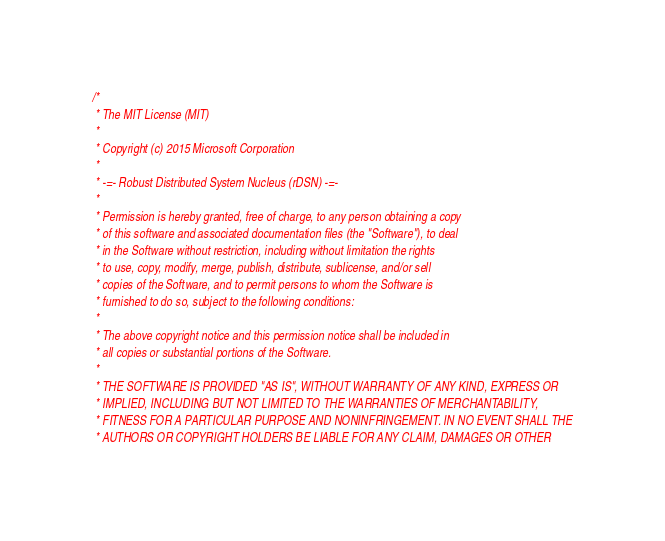Convert code to text. <code><loc_0><loc_0><loc_500><loc_500><_C++_>/*
 * The MIT License (MIT)
 *
 * Copyright (c) 2015 Microsoft Corporation
 *
 * -=- Robust Distributed System Nucleus (rDSN) -=-
 *
 * Permission is hereby granted, free of charge, to any person obtaining a copy
 * of this software and associated documentation files (the "Software"), to deal
 * in the Software without restriction, including without limitation the rights
 * to use, copy, modify, merge, publish, distribute, sublicense, and/or sell
 * copies of the Software, and to permit persons to whom the Software is
 * furnished to do so, subject to the following conditions:
 *
 * The above copyright notice and this permission notice shall be included in
 * all copies or substantial portions of the Software.
 *
 * THE SOFTWARE IS PROVIDED "AS IS", WITHOUT WARRANTY OF ANY KIND, EXPRESS OR
 * IMPLIED, INCLUDING BUT NOT LIMITED TO THE WARRANTIES OF MERCHANTABILITY,
 * FITNESS FOR A PARTICULAR PURPOSE AND NONINFRINGEMENT. IN NO EVENT SHALL THE
 * AUTHORS OR COPYRIGHT HOLDERS BE LIABLE FOR ANY CLAIM, DAMAGES OR OTHER</code> 